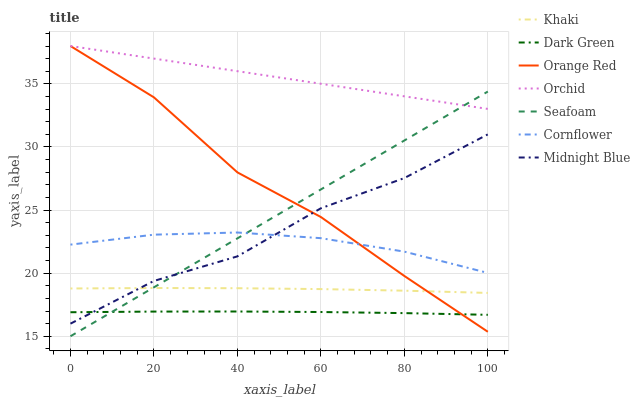Does Dark Green have the minimum area under the curve?
Answer yes or no. Yes. Does Orchid have the maximum area under the curve?
Answer yes or no. Yes. Does Khaki have the minimum area under the curve?
Answer yes or no. No. Does Khaki have the maximum area under the curve?
Answer yes or no. No. Is Seafoam the smoothest?
Answer yes or no. Yes. Is Midnight Blue the roughest?
Answer yes or no. Yes. Is Khaki the smoothest?
Answer yes or no. No. Is Khaki the roughest?
Answer yes or no. No. Does Khaki have the lowest value?
Answer yes or no. No. Does Orchid have the highest value?
Answer yes or no. Yes. Does Khaki have the highest value?
Answer yes or no. No. Is Dark Green less than Orchid?
Answer yes or no. Yes. Is Cornflower greater than Khaki?
Answer yes or no. Yes. Does Seafoam intersect Dark Green?
Answer yes or no. Yes. Is Seafoam less than Dark Green?
Answer yes or no. No. Is Seafoam greater than Dark Green?
Answer yes or no. No. Does Dark Green intersect Orchid?
Answer yes or no. No. 